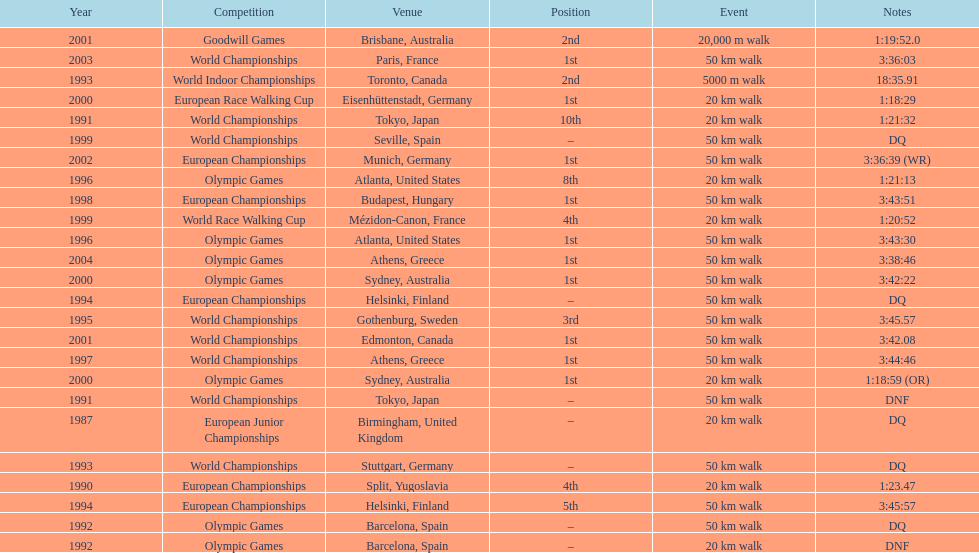What was the difference between korzeniowski's performance at the 1996 olympic games and the 2000 olympic games in the 20 km walk? 2:14. 